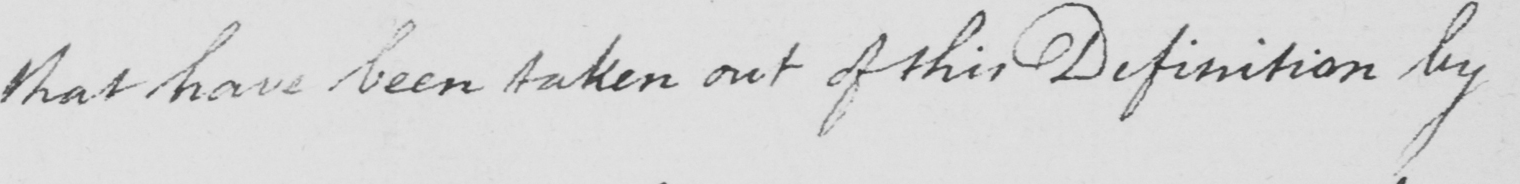Transcribe the text shown in this historical manuscript line. that have been taken out of this Definition by 